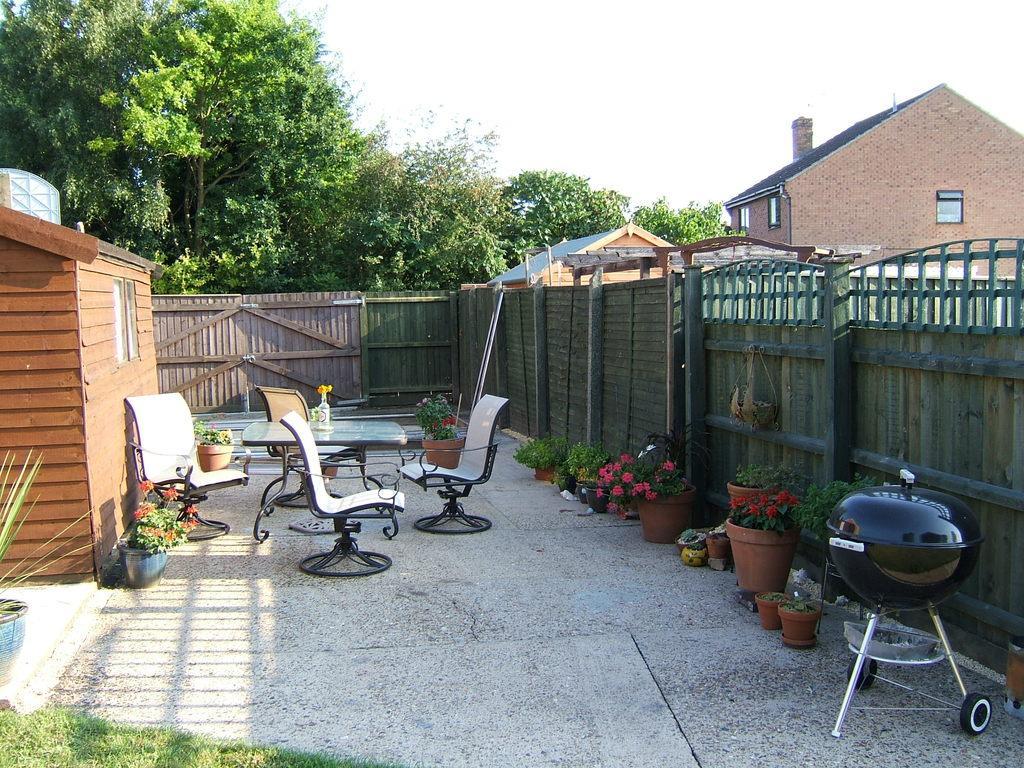How would you summarize this image in a sentence or two? In this picture we can see chairs and a table. These are the plants. Here we can see a house and this is window. These are the trees and there is a sky. 